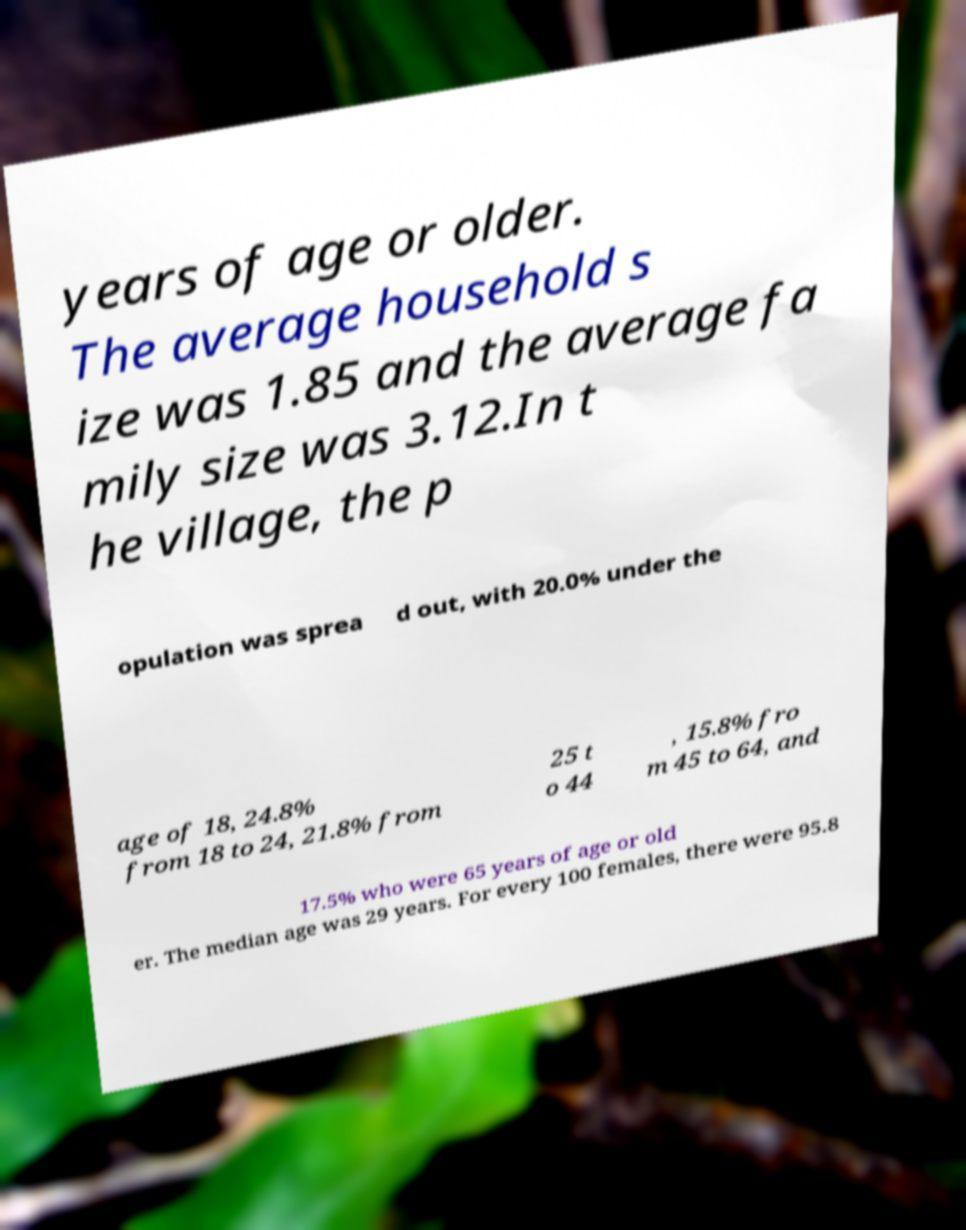For documentation purposes, I need the text within this image transcribed. Could you provide that? years of age or older. The average household s ize was 1.85 and the average fa mily size was 3.12.In t he village, the p opulation was sprea d out, with 20.0% under the age of 18, 24.8% from 18 to 24, 21.8% from 25 t o 44 , 15.8% fro m 45 to 64, and 17.5% who were 65 years of age or old er. The median age was 29 years. For every 100 females, there were 95.8 